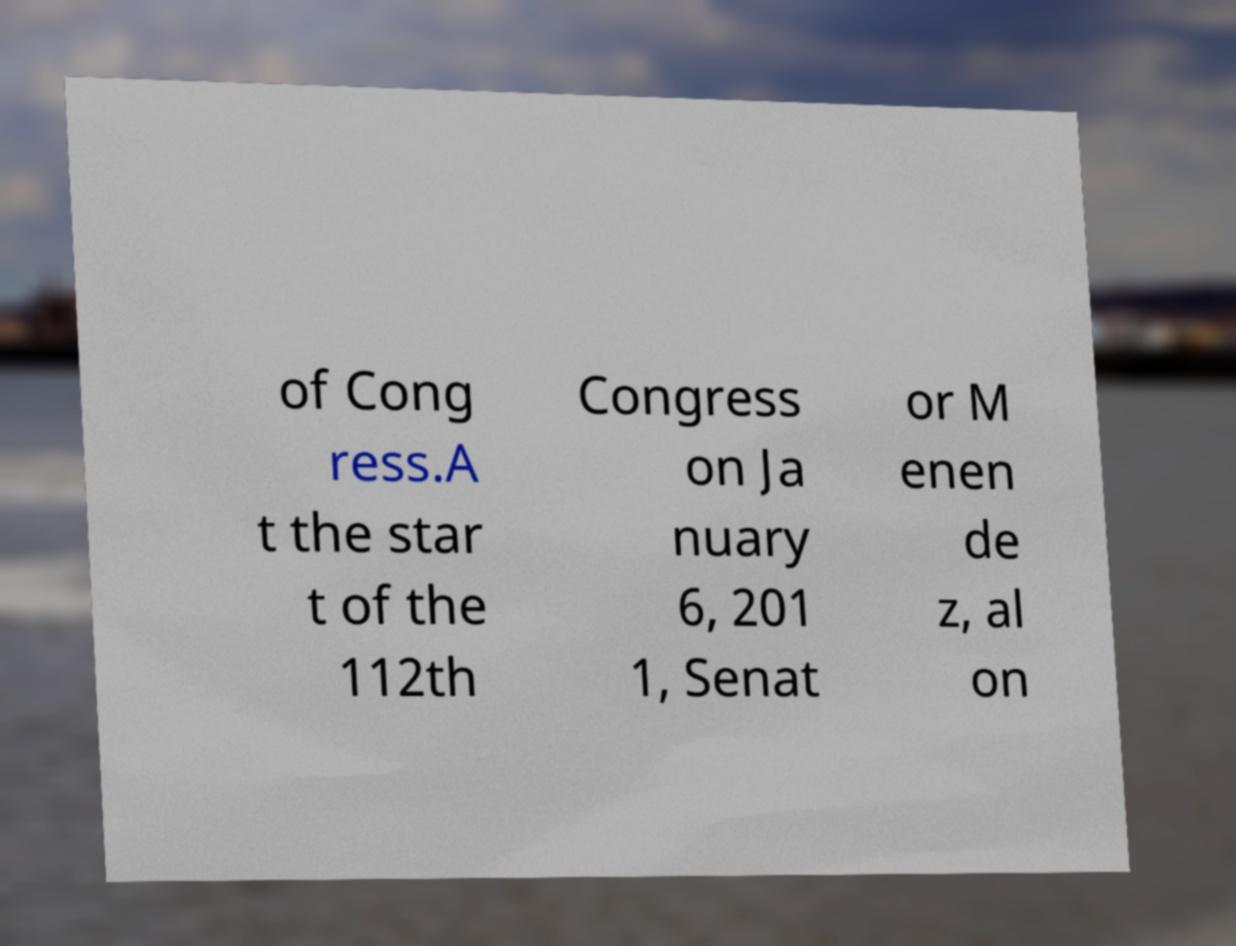Could you extract and type out the text from this image? of Cong ress.A t the star t of the 112th Congress on Ja nuary 6, 201 1, Senat or M enen de z, al on 